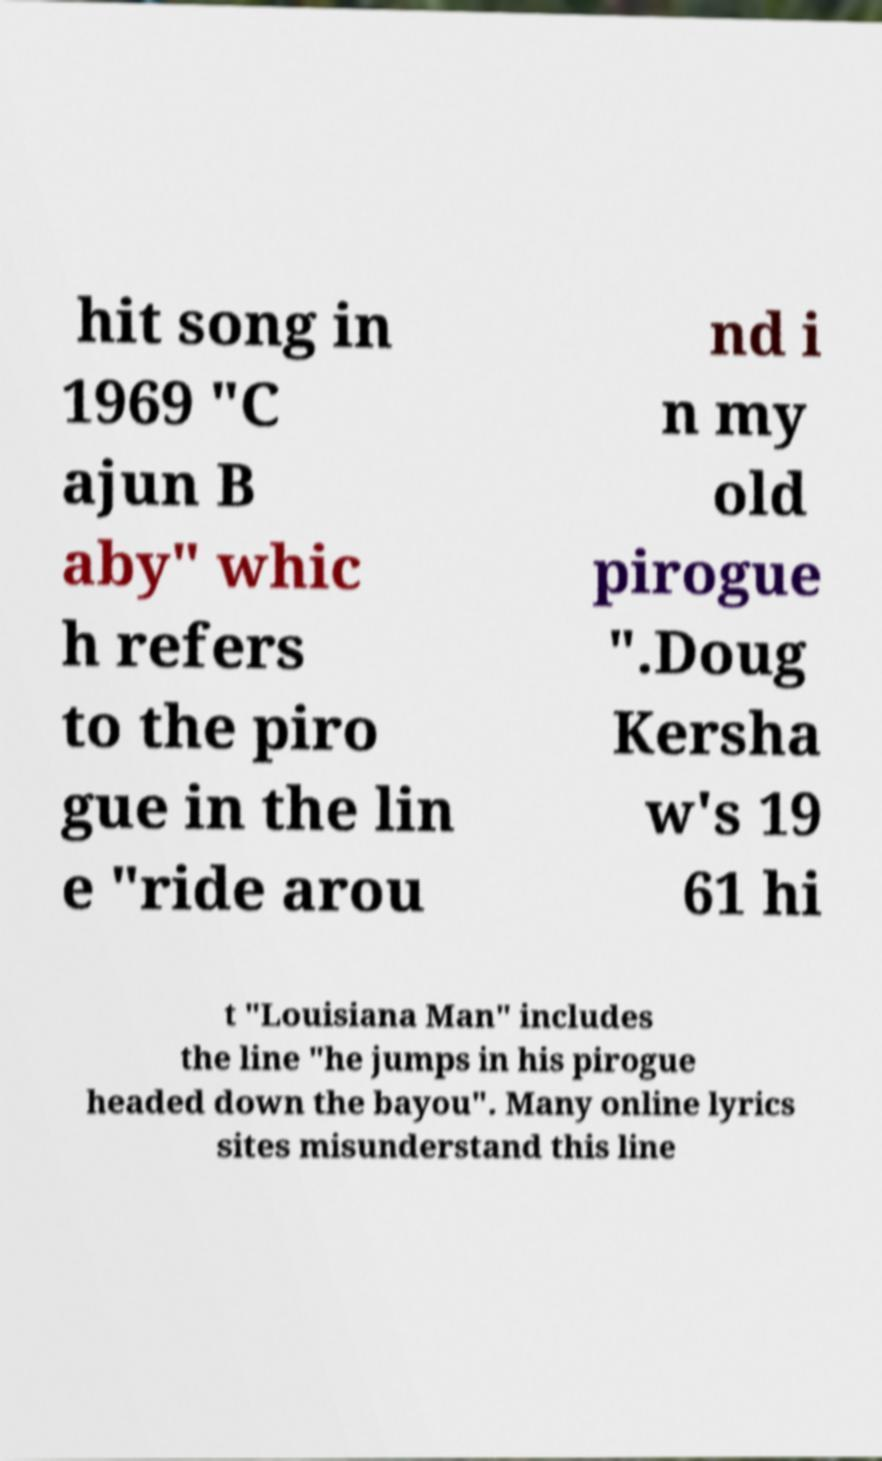Can you read and provide the text displayed in the image?This photo seems to have some interesting text. Can you extract and type it out for me? hit song in 1969 "C ajun B aby" whic h refers to the piro gue in the lin e "ride arou nd i n my old pirogue ".Doug Kersha w's 19 61 hi t "Louisiana Man" includes the line "he jumps in his pirogue headed down the bayou". Many online lyrics sites misunderstand this line 